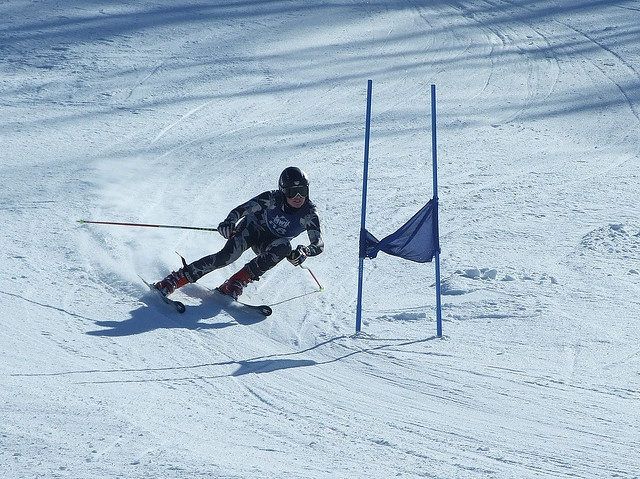Describe the objects in this image and their specific colors. I can see people in gray, black, navy, and darkblue tones and skis in gray, blue, black, and navy tones in this image. 